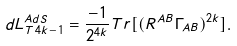Convert formula to latex. <formula><loc_0><loc_0><loc_500><loc_500>d L ^ { A d S } _ { T \, 4 k - 1 } = \frac { - 1 } { 2 ^ { 4 k } } T r [ ( R ^ { A B } \Gamma _ { A B } ) ^ { 2 k } ] .</formula> 